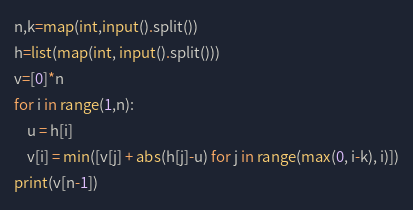Convert code to text. <code><loc_0><loc_0><loc_500><loc_500><_Python_>n,k=map(int,input().split())
h=list(map(int, input().split()))
v=[0]*n
for i in range(1,n):
	u = h[i]
	v[i] = min([v[j] + abs(h[j]-u) for j in range(max(0, i-k), i)])
print(v[n-1])</code> 